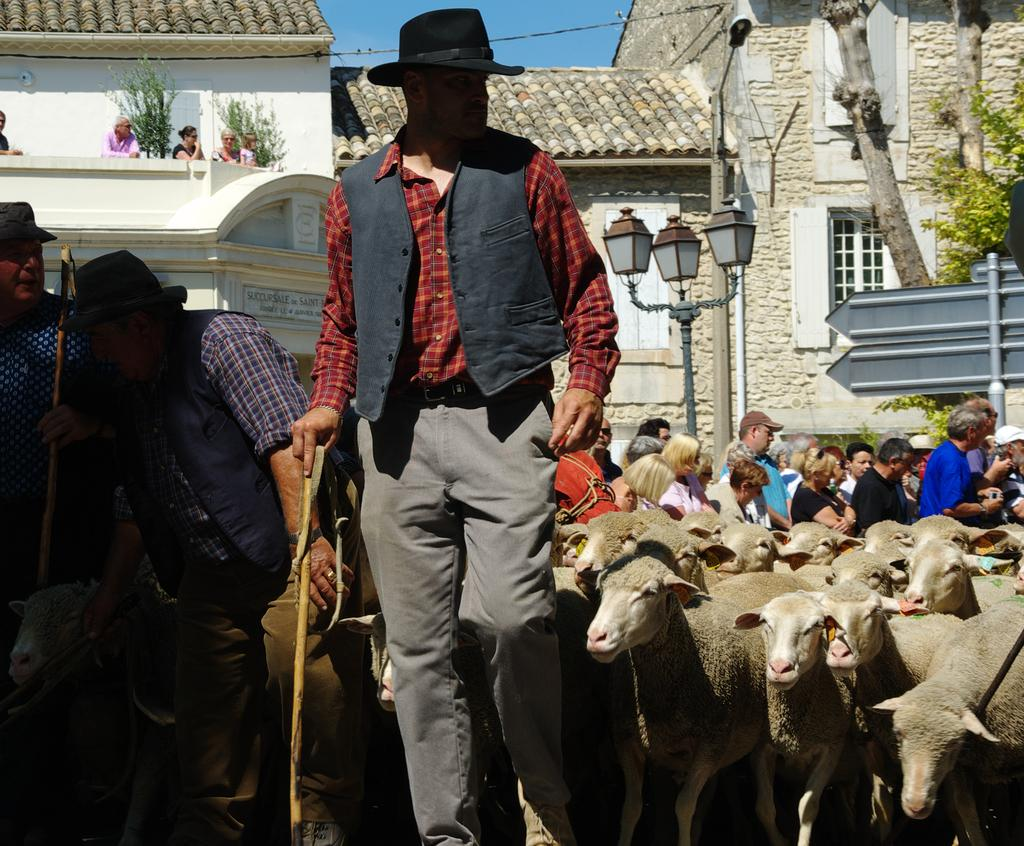What are the three persons in the image doing? The three persons are standing and holding sticks. What animals can be seen in the image? There are sheep in the image. Can you describe the group of people in the image? There is a group of people standing in the image. What type of lighting is present in the image? Lights are visible in the image. What objects are present in the image that might be used for displaying information or advertisements? Boards are present in the image. What objects are present in the image that might be used for support or structure? Poles are present in the image. What type of structures can be seen in the image? Buildings are visible in the image. What type of vegetation can be seen in the image? Plants are present in the image. What type of tree can be seen in the image? There is a tree in the image. What part of the natural environment is visible in the image? The sky is visible in the image. What type of sound can be heard coming from the brick in the image? There is no brick present in the image, and therefore no sound can be heard from it. What type of voice can be heard coming from the sheep in the image? Sheep do not have the ability to produce human-like voices, and there is no indication in the image that any sounds are being made. 